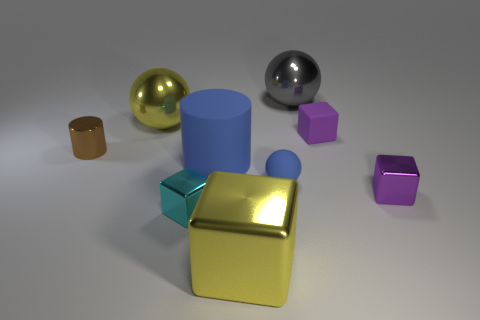Subtract all yellow metallic spheres. How many spheres are left? 2 Subtract all cyan cubes. How many cubes are left? 3 Subtract 2 spheres. How many spheres are left? 1 Subtract all blocks. How many objects are left? 5 Subtract 0 blue blocks. How many objects are left? 9 Subtract all red cylinders. Subtract all cyan cubes. How many cylinders are left? 2 Subtract all yellow balls. How many purple blocks are left? 2 Subtract all big yellow shiny things. Subtract all green shiny things. How many objects are left? 7 Add 8 purple matte objects. How many purple matte objects are left? 9 Add 2 tiny cyan shiny cubes. How many tiny cyan shiny cubes exist? 3 